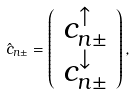Convert formula to latex. <formula><loc_0><loc_0><loc_500><loc_500>\hat { c } _ { n \pm } = \left ( \begin{array} { c } c ^ { \uparrow } _ { n \pm } \\ c ^ { \downarrow } _ { n \pm } \end{array} \right ) ,</formula> 